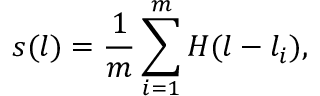<formula> <loc_0><loc_0><loc_500><loc_500>s ( l ) = \frac { 1 } { m } \sum _ { i = 1 } ^ { m } H ( l - l _ { i } ) ,</formula> 